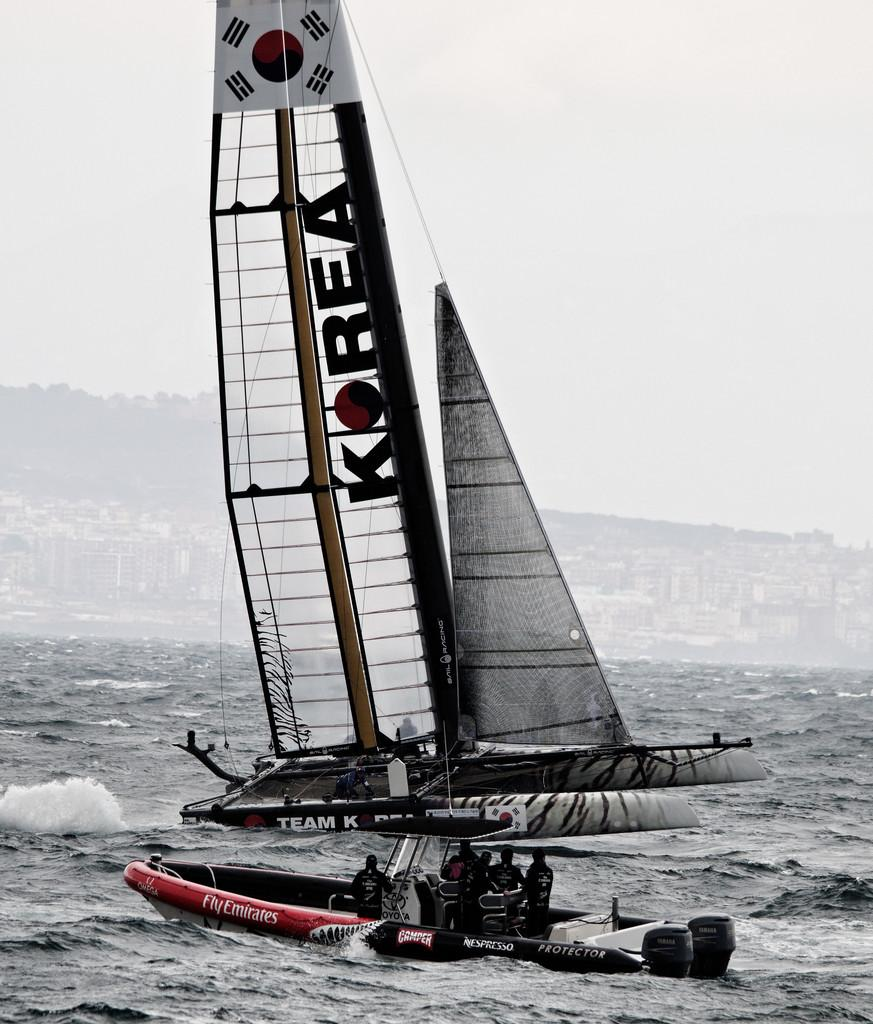What are the people in the image doing? The people in the image are sailing boats. Where are the boats located? The boats are on the water. What can be seen in the background of the image? There are buildings, trees, and the sky visible in the background of the image. What type of beetle can be seen crawling on the boat in the image? There is no beetle present on the boat in the image. What route are the people sailing in the image? The image does not provide information about the route the people are sailing. 